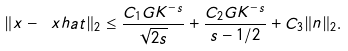<formula> <loc_0><loc_0><loc_500><loc_500>\| x - \ x h a t \| _ { 2 } \leq \frac { C _ { 1 } G K ^ { - s } } { \sqrt { 2 s } } + \frac { C _ { 2 } G K ^ { - s } } { s - 1 / 2 } + C _ { 3 } \| n \| _ { 2 } .</formula> 